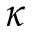Convert formula to latex. <formula><loc_0><loc_0><loc_500><loc_500>\kappa</formula> 